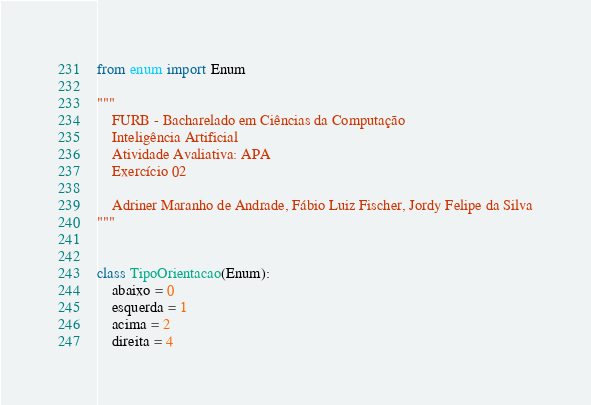Convert code to text. <code><loc_0><loc_0><loc_500><loc_500><_Python_>from enum import Enum

"""
    FURB - Bacharelado em Ciências da Computação
    Inteligência Artificial
    Atividade Avaliativa: APA
    Exercício 02

    Adriner Maranho de Andrade, Fábio Luiz Fischer, Jordy Felipe da Silva
"""


class TipoOrientacao(Enum):
    abaixo = 0
    esquerda = 1
    acima = 2
    direita = 4
</code> 